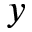<formula> <loc_0><loc_0><loc_500><loc_500>y</formula> 